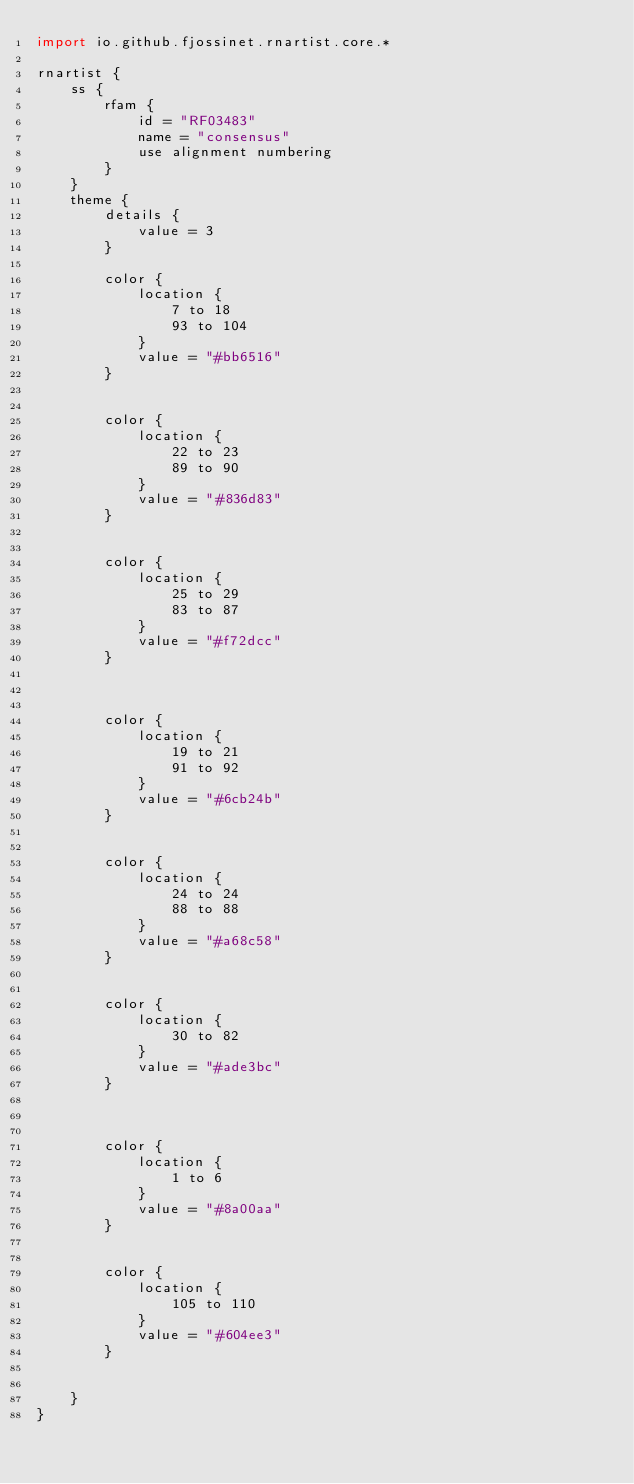<code> <loc_0><loc_0><loc_500><loc_500><_Kotlin_>import io.github.fjossinet.rnartist.core.*      

rnartist {
    ss {
        rfam {
            id = "RF03483"
            name = "consensus"
            use alignment numbering
        }
    }
    theme {
        details { 
            value = 3
        }

        color {
            location {
                7 to 18
                93 to 104
            }
            value = "#bb6516"
        }


        color {
            location {
                22 to 23
                89 to 90
            }
            value = "#836d83"
        }


        color {
            location {
                25 to 29
                83 to 87
            }
            value = "#f72dcc"
        }



        color {
            location {
                19 to 21
                91 to 92
            }
            value = "#6cb24b"
        }


        color {
            location {
                24 to 24
                88 to 88
            }
            value = "#a68c58"
        }


        color {
            location {
                30 to 82
            }
            value = "#ade3bc"
        }



        color {
            location {
                1 to 6
            }
            value = "#8a00aa"
        }


        color {
            location {
                105 to 110
            }
            value = "#604ee3"
        }


    }
}           </code> 